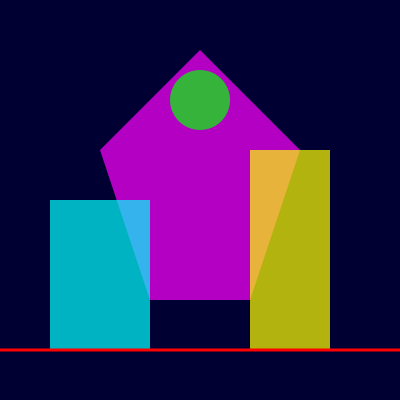In creating a futuristic cityscape with geometric shapes and neon colors, which compositional technique is demonstrated in the image to create depth and visual interest? To answer this question, let's analyze the compositional elements in the provided futuristic cityscape:

1. Overlapping shapes: The geometric forms in the image overlap each other, creating a sense of depth and layering.

2. Size variation: The shapes vary in size, with larger shapes appearing closer and smaller shapes seeming farther away.

3. Color contrast: Neon colors (magenta, cyan, yellow, red, and green) are used against a dark blue background, creating visual interest and a futuristic feel.

4. Opacity: The shapes have varying levels of opacity, allowing for a sense of transparency and dimension.

5. Vertical layering: The shapes are arranged at different heights, suggesting a vertical cityscape.

6. Horizon line: A red line at the bottom of the image acts as a horizon, grounding the composition.

7. Varied geometric forms: The image includes a pentagon, rectangles, and a circle, providing diverse geometric elements.

The key compositional technique demonstrated here is layering. By overlapping shapes of different sizes, colors, and opacities, the image creates a sense of depth and dimension, which is crucial in representing a complex cityscape. This layering technique allows for a dynamic and visually interesting composition that effectively conveys a futuristic urban environment.
Answer: Layering 